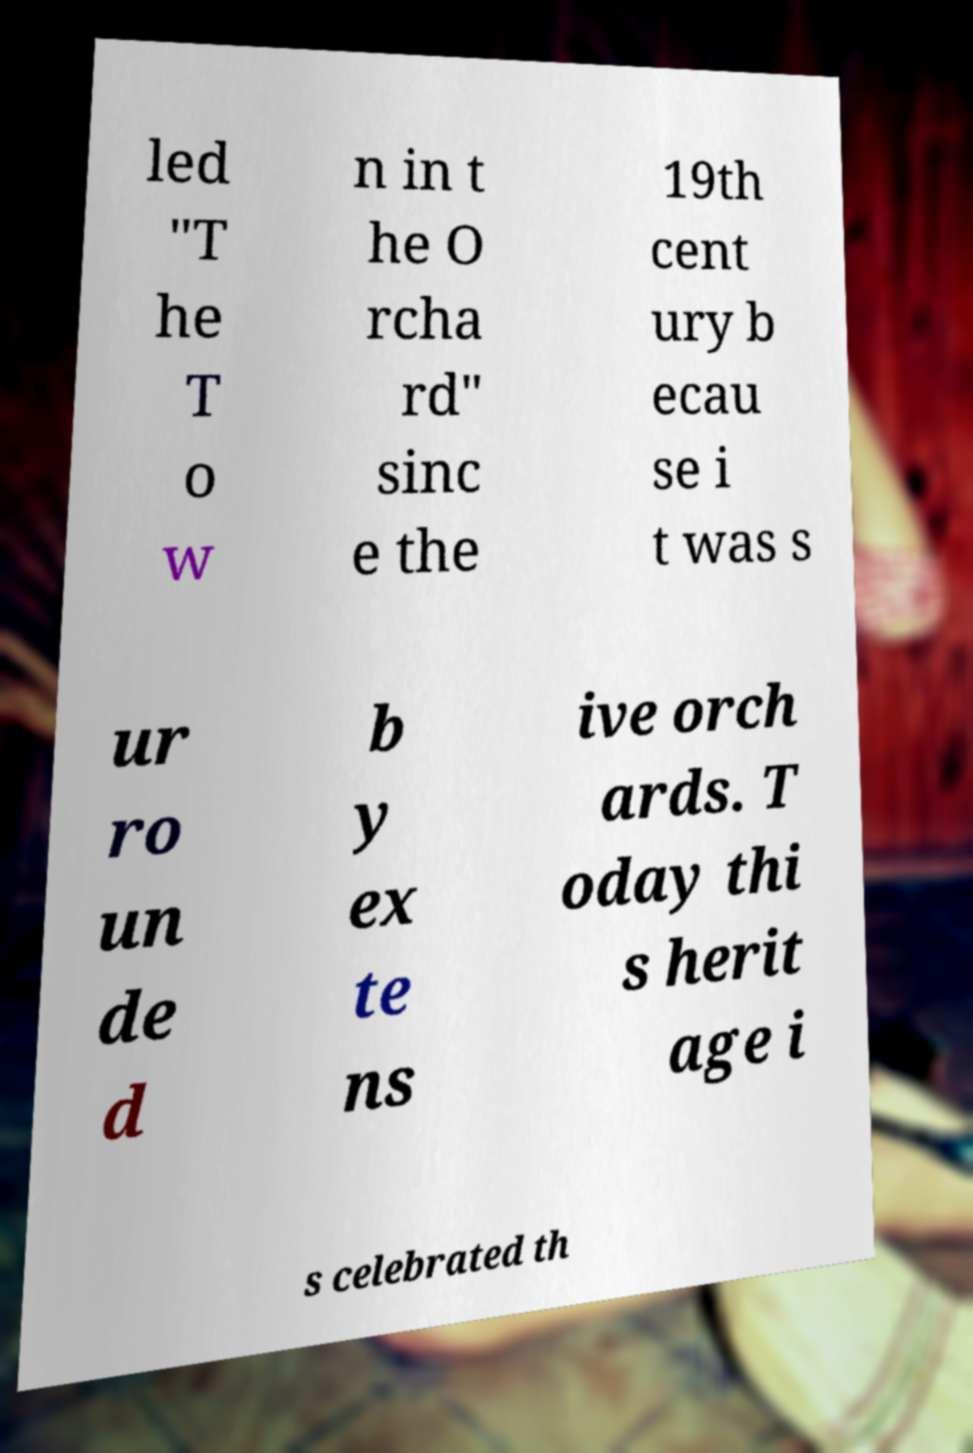I need the written content from this picture converted into text. Can you do that? led "T he T o w n in t he O rcha rd" sinc e the 19th cent ury b ecau se i t was s ur ro un de d b y ex te ns ive orch ards. T oday thi s herit age i s celebrated th 